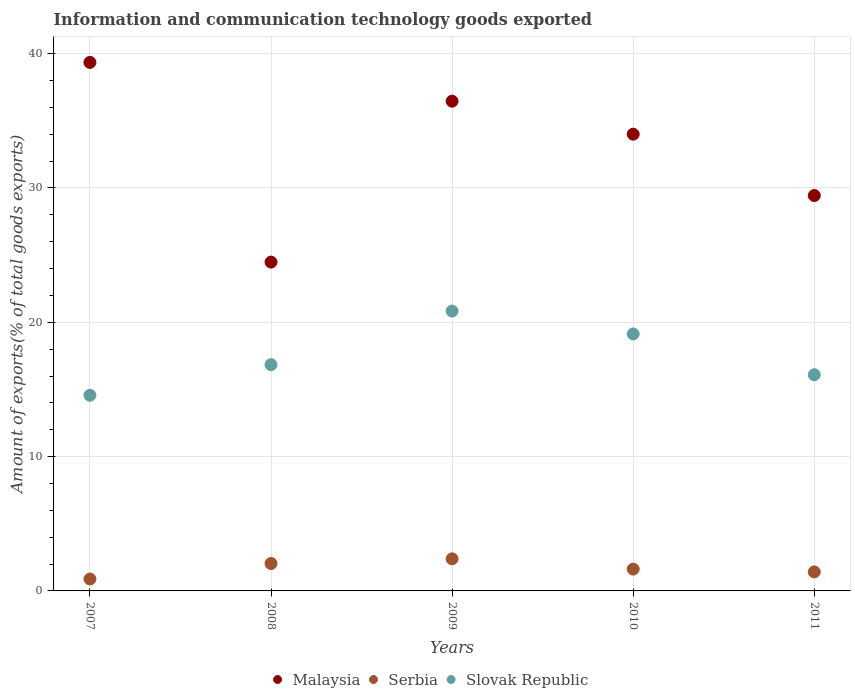How many different coloured dotlines are there?
Make the answer very short. 3. Is the number of dotlines equal to the number of legend labels?
Ensure brevity in your answer.  Yes. What is the amount of goods exported in Slovak Republic in 2008?
Keep it short and to the point. 16.84. Across all years, what is the maximum amount of goods exported in Malaysia?
Give a very brief answer. 39.35. Across all years, what is the minimum amount of goods exported in Malaysia?
Give a very brief answer. 24.48. What is the total amount of goods exported in Malaysia in the graph?
Your answer should be very brief. 163.74. What is the difference between the amount of goods exported in Serbia in 2007 and that in 2011?
Offer a terse response. -0.53. What is the difference between the amount of goods exported in Slovak Republic in 2008 and the amount of goods exported in Serbia in 2010?
Offer a very short reply. 15.22. What is the average amount of goods exported in Slovak Republic per year?
Give a very brief answer. 17.5. In the year 2010, what is the difference between the amount of goods exported in Serbia and amount of goods exported in Malaysia?
Your answer should be very brief. -32.38. In how many years, is the amount of goods exported in Slovak Republic greater than 36 %?
Provide a short and direct response. 0. What is the ratio of the amount of goods exported in Serbia in 2007 to that in 2008?
Provide a succinct answer. 0.43. Is the difference between the amount of goods exported in Serbia in 2009 and 2010 greater than the difference between the amount of goods exported in Malaysia in 2009 and 2010?
Offer a very short reply. No. What is the difference between the highest and the second highest amount of goods exported in Serbia?
Provide a short and direct response. 0.35. What is the difference between the highest and the lowest amount of goods exported in Serbia?
Provide a short and direct response. 1.5. Is the sum of the amount of goods exported in Serbia in 2007 and 2011 greater than the maximum amount of goods exported in Malaysia across all years?
Ensure brevity in your answer.  No. Is it the case that in every year, the sum of the amount of goods exported in Slovak Republic and amount of goods exported in Malaysia  is greater than the amount of goods exported in Serbia?
Your response must be concise. Yes. How many dotlines are there?
Offer a very short reply. 3. Does the graph contain grids?
Provide a short and direct response. Yes. Where does the legend appear in the graph?
Ensure brevity in your answer.  Bottom center. What is the title of the graph?
Make the answer very short. Information and communication technology goods exported. Does "Luxembourg" appear as one of the legend labels in the graph?
Make the answer very short. No. What is the label or title of the X-axis?
Offer a terse response. Years. What is the label or title of the Y-axis?
Provide a succinct answer. Amount of exports(% of total goods exports). What is the Amount of exports(% of total goods exports) of Malaysia in 2007?
Offer a terse response. 39.35. What is the Amount of exports(% of total goods exports) of Serbia in 2007?
Offer a terse response. 0.89. What is the Amount of exports(% of total goods exports) in Slovak Republic in 2007?
Provide a short and direct response. 14.57. What is the Amount of exports(% of total goods exports) in Malaysia in 2008?
Keep it short and to the point. 24.48. What is the Amount of exports(% of total goods exports) of Serbia in 2008?
Your answer should be very brief. 2.04. What is the Amount of exports(% of total goods exports) in Slovak Republic in 2008?
Offer a terse response. 16.84. What is the Amount of exports(% of total goods exports) in Malaysia in 2009?
Your answer should be very brief. 36.46. What is the Amount of exports(% of total goods exports) of Serbia in 2009?
Give a very brief answer. 2.39. What is the Amount of exports(% of total goods exports) of Slovak Republic in 2009?
Make the answer very short. 20.83. What is the Amount of exports(% of total goods exports) of Malaysia in 2010?
Offer a very short reply. 34.01. What is the Amount of exports(% of total goods exports) in Serbia in 2010?
Offer a terse response. 1.63. What is the Amount of exports(% of total goods exports) of Slovak Republic in 2010?
Provide a succinct answer. 19.13. What is the Amount of exports(% of total goods exports) in Malaysia in 2011?
Your answer should be compact. 29.44. What is the Amount of exports(% of total goods exports) in Serbia in 2011?
Provide a succinct answer. 1.42. What is the Amount of exports(% of total goods exports) in Slovak Republic in 2011?
Offer a very short reply. 16.1. Across all years, what is the maximum Amount of exports(% of total goods exports) of Malaysia?
Your answer should be compact. 39.35. Across all years, what is the maximum Amount of exports(% of total goods exports) of Serbia?
Give a very brief answer. 2.39. Across all years, what is the maximum Amount of exports(% of total goods exports) of Slovak Republic?
Make the answer very short. 20.83. Across all years, what is the minimum Amount of exports(% of total goods exports) of Malaysia?
Keep it short and to the point. 24.48. Across all years, what is the minimum Amount of exports(% of total goods exports) in Serbia?
Your answer should be compact. 0.89. Across all years, what is the minimum Amount of exports(% of total goods exports) in Slovak Republic?
Offer a very short reply. 14.57. What is the total Amount of exports(% of total goods exports) in Malaysia in the graph?
Keep it short and to the point. 163.74. What is the total Amount of exports(% of total goods exports) in Serbia in the graph?
Offer a very short reply. 8.36. What is the total Amount of exports(% of total goods exports) of Slovak Republic in the graph?
Your answer should be compact. 87.48. What is the difference between the Amount of exports(% of total goods exports) of Malaysia in 2007 and that in 2008?
Your answer should be compact. 14.87. What is the difference between the Amount of exports(% of total goods exports) of Serbia in 2007 and that in 2008?
Make the answer very short. -1.15. What is the difference between the Amount of exports(% of total goods exports) of Slovak Republic in 2007 and that in 2008?
Make the answer very short. -2.28. What is the difference between the Amount of exports(% of total goods exports) of Malaysia in 2007 and that in 2009?
Your answer should be very brief. 2.89. What is the difference between the Amount of exports(% of total goods exports) in Serbia in 2007 and that in 2009?
Make the answer very short. -1.5. What is the difference between the Amount of exports(% of total goods exports) in Slovak Republic in 2007 and that in 2009?
Provide a succinct answer. -6.27. What is the difference between the Amount of exports(% of total goods exports) of Malaysia in 2007 and that in 2010?
Offer a very short reply. 5.34. What is the difference between the Amount of exports(% of total goods exports) of Serbia in 2007 and that in 2010?
Your answer should be compact. -0.74. What is the difference between the Amount of exports(% of total goods exports) in Slovak Republic in 2007 and that in 2010?
Your response must be concise. -4.57. What is the difference between the Amount of exports(% of total goods exports) of Malaysia in 2007 and that in 2011?
Your response must be concise. 9.91. What is the difference between the Amount of exports(% of total goods exports) of Serbia in 2007 and that in 2011?
Offer a terse response. -0.53. What is the difference between the Amount of exports(% of total goods exports) in Slovak Republic in 2007 and that in 2011?
Offer a very short reply. -1.53. What is the difference between the Amount of exports(% of total goods exports) in Malaysia in 2008 and that in 2009?
Offer a terse response. -11.98. What is the difference between the Amount of exports(% of total goods exports) in Serbia in 2008 and that in 2009?
Your answer should be very brief. -0.35. What is the difference between the Amount of exports(% of total goods exports) of Slovak Republic in 2008 and that in 2009?
Give a very brief answer. -3.99. What is the difference between the Amount of exports(% of total goods exports) in Malaysia in 2008 and that in 2010?
Provide a succinct answer. -9.52. What is the difference between the Amount of exports(% of total goods exports) of Serbia in 2008 and that in 2010?
Your answer should be very brief. 0.41. What is the difference between the Amount of exports(% of total goods exports) of Slovak Republic in 2008 and that in 2010?
Ensure brevity in your answer.  -2.29. What is the difference between the Amount of exports(% of total goods exports) of Malaysia in 2008 and that in 2011?
Keep it short and to the point. -4.96. What is the difference between the Amount of exports(% of total goods exports) in Serbia in 2008 and that in 2011?
Your answer should be compact. 0.63. What is the difference between the Amount of exports(% of total goods exports) in Slovak Republic in 2008 and that in 2011?
Your response must be concise. 0.75. What is the difference between the Amount of exports(% of total goods exports) in Malaysia in 2009 and that in 2010?
Your response must be concise. 2.46. What is the difference between the Amount of exports(% of total goods exports) of Serbia in 2009 and that in 2010?
Keep it short and to the point. 0.76. What is the difference between the Amount of exports(% of total goods exports) in Slovak Republic in 2009 and that in 2010?
Provide a succinct answer. 1.7. What is the difference between the Amount of exports(% of total goods exports) of Malaysia in 2009 and that in 2011?
Offer a terse response. 7.02. What is the difference between the Amount of exports(% of total goods exports) in Serbia in 2009 and that in 2011?
Provide a succinct answer. 0.97. What is the difference between the Amount of exports(% of total goods exports) in Slovak Republic in 2009 and that in 2011?
Make the answer very short. 4.74. What is the difference between the Amount of exports(% of total goods exports) in Malaysia in 2010 and that in 2011?
Ensure brevity in your answer.  4.57. What is the difference between the Amount of exports(% of total goods exports) of Serbia in 2010 and that in 2011?
Provide a short and direct response. 0.21. What is the difference between the Amount of exports(% of total goods exports) in Slovak Republic in 2010 and that in 2011?
Your response must be concise. 3.04. What is the difference between the Amount of exports(% of total goods exports) in Malaysia in 2007 and the Amount of exports(% of total goods exports) in Serbia in 2008?
Ensure brevity in your answer.  37.31. What is the difference between the Amount of exports(% of total goods exports) in Malaysia in 2007 and the Amount of exports(% of total goods exports) in Slovak Republic in 2008?
Your answer should be compact. 22.51. What is the difference between the Amount of exports(% of total goods exports) in Serbia in 2007 and the Amount of exports(% of total goods exports) in Slovak Republic in 2008?
Give a very brief answer. -15.96. What is the difference between the Amount of exports(% of total goods exports) in Malaysia in 2007 and the Amount of exports(% of total goods exports) in Serbia in 2009?
Provide a short and direct response. 36.96. What is the difference between the Amount of exports(% of total goods exports) in Malaysia in 2007 and the Amount of exports(% of total goods exports) in Slovak Republic in 2009?
Offer a terse response. 18.52. What is the difference between the Amount of exports(% of total goods exports) of Serbia in 2007 and the Amount of exports(% of total goods exports) of Slovak Republic in 2009?
Make the answer very short. -19.95. What is the difference between the Amount of exports(% of total goods exports) in Malaysia in 2007 and the Amount of exports(% of total goods exports) in Serbia in 2010?
Your answer should be compact. 37.72. What is the difference between the Amount of exports(% of total goods exports) in Malaysia in 2007 and the Amount of exports(% of total goods exports) in Slovak Republic in 2010?
Your answer should be compact. 20.22. What is the difference between the Amount of exports(% of total goods exports) in Serbia in 2007 and the Amount of exports(% of total goods exports) in Slovak Republic in 2010?
Give a very brief answer. -18.25. What is the difference between the Amount of exports(% of total goods exports) of Malaysia in 2007 and the Amount of exports(% of total goods exports) of Serbia in 2011?
Your response must be concise. 37.94. What is the difference between the Amount of exports(% of total goods exports) of Malaysia in 2007 and the Amount of exports(% of total goods exports) of Slovak Republic in 2011?
Your answer should be very brief. 23.25. What is the difference between the Amount of exports(% of total goods exports) of Serbia in 2007 and the Amount of exports(% of total goods exports) of Slovak Republic in 2011?
Give a very brief answer. -15.21. What is the difference between the Amount of exports(% of total goods exports) in Malaysia in 2008 and the Amount of exports(% of total goods exports) in Serbia in 2009?
Your response must be concise. 22.09. What is the difference between the Amount of exports(% of total goods exports) of Malaysia in 2008 and the Amount of exports(% of total goods exports) of Slovak Republic in 2009?
Offer a terse response. 3.65. What is the difference between the Amount of exports(% of total goods exports) of Serbia in 2008 and the Amount of exports(% of total goods exports) of Slovak Republic in 2009?
Offer a very short reply. -18.79. What is the difference between the Amount of exports(% of total goods exports) of Malaysia in 2008 and the Amount of exports(% of total goods exports) of Serbia in 2010?
Your answer should be very brief. 22.86. What is the difference between the Amount of exports(% of total goods exports) in Malaysia in 2008 and the Amount of exports(% of total goods exports) in Slovak Republic in 2010?
Ensure brevity in your answer.  5.35. What is the difference between the Amount of exports(% of total goods exports) of Serbia in 2008 and the Amount of exports(% of total goods exports) of Slovak Republic in 2010?
Provide a short and direct response. -17.09. What is the difference between the Amount of exports(% of total goods exports) in Malaysia in 2008 and the Amount of exports(% of total goods exports) in Serbia in 2011?
Your answer should be very brief. 23.07. What is the difference between the Amount of exports(% of total goods exports) in Malaysia in 2008 and the Amount of exports(% of total goods exports) in Slovak Republic in 2011?
Your answer should be very brief. 8.39. What is the difference between the Amount of exports(% of total goods exports) in Serbia in 2008 and the Amount of exports(% of total goods exports) in Slovak Republic in 2011?
Give a very brief answer. -14.06. What is the difference between the Amount of exports(% of total goods exports) in Malaysia in 2009 and the Amount of exports(% of total goods exports) in Serbia in 2010?
Offer a very short reply. 34.84. What is the difference between the Amount of exports(% of total goods exports) of Malaysia in 2009 and the Amount of exports(% of total goods exports) of Slovak Republic in 2010?
Give a very brief answer. 17.33. What is the difference between the Amount of exports(% of total goods exports) in Serbia in 2009 and the Amount of exports(% of total goods exports) in Slovak Republic in 2010?
Provide a short and direct response. -16.74. What is the difference between the Amount of exports(% of total goods exports) of Malaysia in 2009 and the Amount of exports(% of total goods exports) of Serbia in 2011?
Keep it short and to the point. 35.05. What is the difference between the Amount of exports(% of total goods exports) of Malaysia in 2009 and the Amount of exports(% of total goods exports) of Slovak Republic in 2011?
Give a very brief answer. 20.37. What is the difference between the Amount of exports(% of total goods exports) in Serbia in 2009 and the Amount of exports(% of total goods exports) in Slovak Republic in 2011?
Ensure brevity in your answer.  -13.71. What is the difference between the Amount of exports(% of total goods exports) in Malaysia in 2010 and the Amount of exports(% of total goods exports) in Serbia in 2011?
Give a very brief answer. 32.59. What is the difference between the Amount of exports(% of total goods exports) of Malaysia in 2010 and the Amount of exports(% of total goods exports) of Slovak Republic in 2011?
Offer a very short reply. 17.91. What is the difference between the Amount of exports(% of total goods exports) of Serbia in 2010 and the Amount of exports(% of total goods exports) of Slovak Republic in 2011?
Offer a terse response. -14.47. What is the average Amount of exports(% of total goods exports) of Malaysia per year?
Make the answer very short. 32.75. What is the average Amount of exports(% of total goods exports) in Serbia per year?
Make the answer very short. 1.67. What is the average Amount of exports(% of total goods exports) of Slovak Republic per year?
Offer a terse response. 17.5. In the year 2007, what is the difference between the Amount of exports(% of total goods exports) of Malaysia and Amount of exports(% of total goods exports) of Serbia?
Keep it short and to the point. 38.46. In the year 2007, what is the difference between the Amount of exports(% of total goods exports) in Malaysia and Amount of exports(% of total goods exports) in Slovak Republic?
Provide a short and direct response. 24.78. In the year 2007, what is the difference between the Amount of exports(% of total goods exports) in Serbia and Amount of exports(% of total goods exports) in Slovak Republic?
Provide a succinct answer. -13.68. In the year 2008, what is the difference between the Amount of exports(% of total goods exports) of Malaysia and Amount of exports(% of total goods exports) of Serbia?
Keep it short and to the point. 22.44. In the year 2008, what is the difference between the Amount of exports(% of total goods exports) in Malaysia and Amount of exports(% of total goods exports) in Slovak Republic?
Provide a succinct answer. 7.64. In the year 2008, what is the difference between the Amount of exports(% of total goods exports) in Serbia and Amount of exports(% of total goods exports) in Slovak Republic?
Give a very brief answer. -14.8. In the year 2009, what is the difference between the Amount of exports(% of total goods exports) in Malaysia and Amount of exports(% of total goods exports) in Serbia?
Offer a very short reply. 34.07. In the year 2009, what is the difference between the Amount of exports(% of total goods exports) in Malaysia and Amount of exports(% of total goods exports) in Slovak Republic?
Give a very brief answer. 15.63. In the year 2009, what is the difference between the Amount of exports(% of total goods exports) of Serbia and Amount of exports(% of total goods exports) of Slovak Republic?
Offer a terse response. -18.44. In the year 2010, what is the difference between the Amount of exports(% of total goods exports) of Malaysia and Amount of exports(% of total goods exports) of Serbia?
Provide a succinct answer. 32.38. In the year 2010, what is the difference between the Amount of exports(% of total goods exports) in Malaysia and Amount of exports(% of total goods exports) in Slovak Republic?
Make the answer very short. 14.87. In the year 2010, what is the difference between the Amount of exports(% of total goods exports) in Serbia and Amount of exports(% of total goods exports) in Slovak Republic?
Give a very brief answer. -17.51. In the year 2011, what is the difference between the Amount of exports(% of total goods exports) of Malaysia and Amount of exports(% of total goods exports) of Serbia?
Your answer should be very brief. 28.02. In the year 2011, what is the difference between the Amount of exports(% of total goods exports) in Malaysia and Amount of exports(% of total goods exports) in Slovak Republic?
Offer a very short reply. 13.34. In the year 2011, what is the difference between the Amount of exports(% of total goods exports) of Serbia and Amount of exports(% of total goods exports) of Slovak Republic?
Your answer should be very brief. -14.68. What is the ratio of the Amount of exports(% of total goods exports) of Malaysia in 2007 to that in 2008?
Keep it short and to the point. 1.61. What is the ratio of the Amount of exports(% of total goods exports) in Serbia in 2007 to that in 2008?
Provide a succinct answer. 0.43. What is the ratio of the Amount of exports(% of total goods exports) of Slovak Republic in 2007 to that in 2008?
Your answer should be very brief. 0.86. What is the ratio of the Amount of exports(% of total goods exports) of Malaysia in 2007 to that in 2009?
Ensure brevity in your answer.  1.08. What is the ratio of the Amount of exports(% of total goods exports) of Serbia in 2007 to that in 2009?
Your answer should be very brief. 0.37. What is the ratio of the Amount of exports(% of total goods exports) of Slovak Republic in 2007 to that in 2009?
Ensure brevity in your answer.  0.7. What is the ratio of the Amount of exports(% of total goods exports) in Malaysia in 2007 to that in 2010?
Provide a succinct answer. 1.16. What is the ratio of the Amount of exports(% of total goods exports) of Serbia in 2007 to that in 2010?
Make the answer very short. 0.55. What is the ratio of the Amount of exports(% of total goods exports) in Slovak Republic in 2007 to that in 2010?
Make the answer very short. 0.76. What is the ratio of the Amount of exports(% of total goods exports) in Malaysia in 2007 to that in 2011?
Make the answer very short. 1.34. What is the ratio of the Amount of exports(% of total goods exports) of Serbia in 2007 to that in 2011?
Provide a short and direct response. 0.63. What is the ratio of the Amount of exports(% of total goods exports) in Slovak Republic in 2007 to that in 2011?
Provide a short and direct response. 0.91. What is the ratio of the Amount of exports(% of total goods exports) of Malaysia in 2008 to that in 2009?
Make the answer very short. 0.67. What is the ratio of the Amount of exports(% of total goods exports) of Serbia in 2008 to that in 2009?
Offer a very short reply. 0.85. What is the ratio of the Amount of exports(% of total goods exports) in Slovak Republic in 2008 to that in 2009?
Give a very brief answer. 0.81. What is the ratio of the Amount of exports(% of total goods exports) of Malaysia in 2008 to that in 2010?
Your response must be concise. 0.72. What is the ratio of the Amount of exports(% of total goods exports) of Serbia in 2008 to that in 2010?
Ensure brevity in your answer.  1.26. What is the ratio of the Amount of exports(% of total goods exports) of Slovak Republic in 2008 to that in 2010?
Offer a terse response. 0.88. What is the ratio of the Amount of exports(% of total goods exports) in Malaysia in 2008 to that in 2011?
Your response must be concise. 0.83. What is the ratio of the Amount of exports(% of total goods exports) of Serbia in 2008 to that in 2011?
Your answer should be compact. 1.44. What is the ratio of the Amount of exports(% of total goods exports) in Slovak Republic in 2008 to that in 2011?
Make the answer very short. 1.05. What is the ratio of the Amount of exports(% of total goods exports) of Malaysia in 2009 to that in 2010?
Make the answer very short. 1.07. What is the ratio of the Amount of exports(% of total goods exports) in Serbia in 2009 to that in 2010?
Keep it short and to the point. 1.47. What is the ratio of the Amount of exports(% of total goods exports) of Slovak Republic in 2009 to that in 2010?
Make the answer very short. 1.09. What is the ratio of the Amount of exports(% of total goods exports) of Malaysia in 2009 to that in 2011?
Keep it short and to the point. 1.24. What is the ratio of the Amount of exports(% of total goods exports) of Serbia in 2009 to that in 2011?
Your answer should be compact. 1.69. What is the ratio of the Amount of exports(% of total goods exports) of Slovak Republic in 2009 to that in 2011?
Make the answer very short. 1.29. What is the ratio of the Amount of exports(% of total goods exports) in Malaysia in 2010 to that in 2011?
Keep it short and to the point. 1.16. What is the ratio of the Amount of exports(% of total goods exports) of Serbia in 2010 to that in 2011?
Offer a terse response. 1.15. What is the ratio of the Amount of exports(% of total goods exports) of Slovak Republic in 2010 to that in 2011?
Your response must be concise. 1.19. What is the difference between the highest and the second highest Amount of exports(% of total goods exports) of Malaysia?
Keep it short and to the point. 2.89. What is the difference between the highest and the second highest Amount of exports(% of total goods exports) of Serbia?
Make the answer very short. 0.35. What is the difference between the highest and the second highest Amount of exports(% of total goods exports) of Slovak Republic?
Ensure brevity in your answer.  1.7. What is the difference between the highest and the lowest Amount of exports(% of total goods exports) of Malaysia?
Ensure brevity in your answer.  14.87. What is the difference between the highest and the lowest Amount of exports(% of total goods exports) of Serbia?
Your answer should be very brief. 1.5. What is the difference between the highest and the lowest Amount of exports(% of total goods exports) in Slovak Republic?
Make the answer very short. 6.27. 